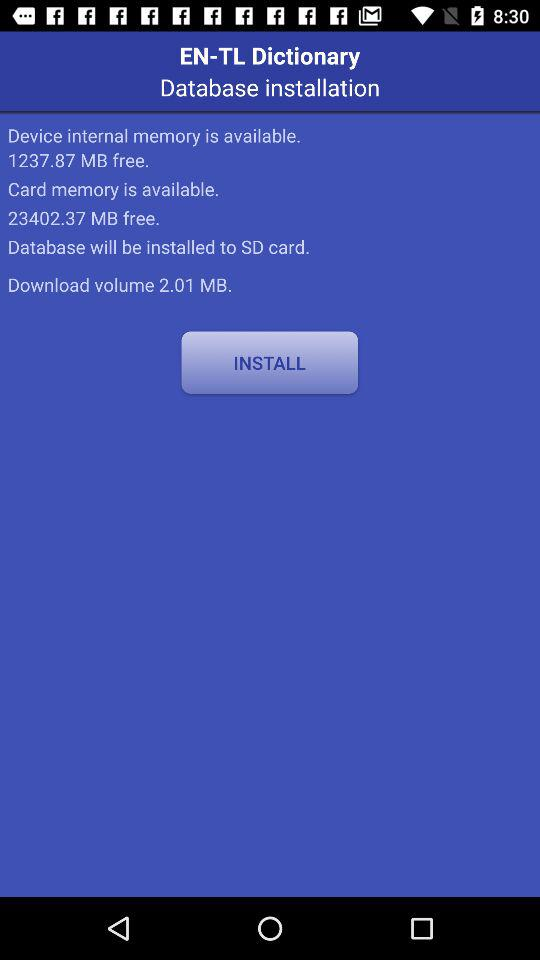What is the size of the free space available in the device's internal memory? The size of the free space available in the device's internal memory is 1237.87 MB. 